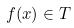Convert formula to latex. <formula><loc_0><loc_0><loc_500><loc_500>f ( x ) \in T</formula> 